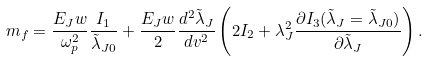<formula> <loc_0><loc_0><loc_500><loc_500>m _ { f } = \frac { E _ { J } w } { \omega ^ { 2 } _ { p } } \frac { I _ { 1 } } { \tilde { \lambda } _ { J 0 } } + \frac { E _ { J } w } { 2 } \frac { d ^ { 2 } \tilde { \lambda } _ { J } } { d v ^ { 2 } } \left ( 2 I _ { 2 } + \lambda _ { J } ^ { 2 } \frac { \partial I _ { 3 } ( { \tilde { \lambda } } _ { J } = { \tilde { \lambda } } _ { J 0 } ) } { \partial { \tilde { \lambda } } _ { J } } \right ) .</formula> 